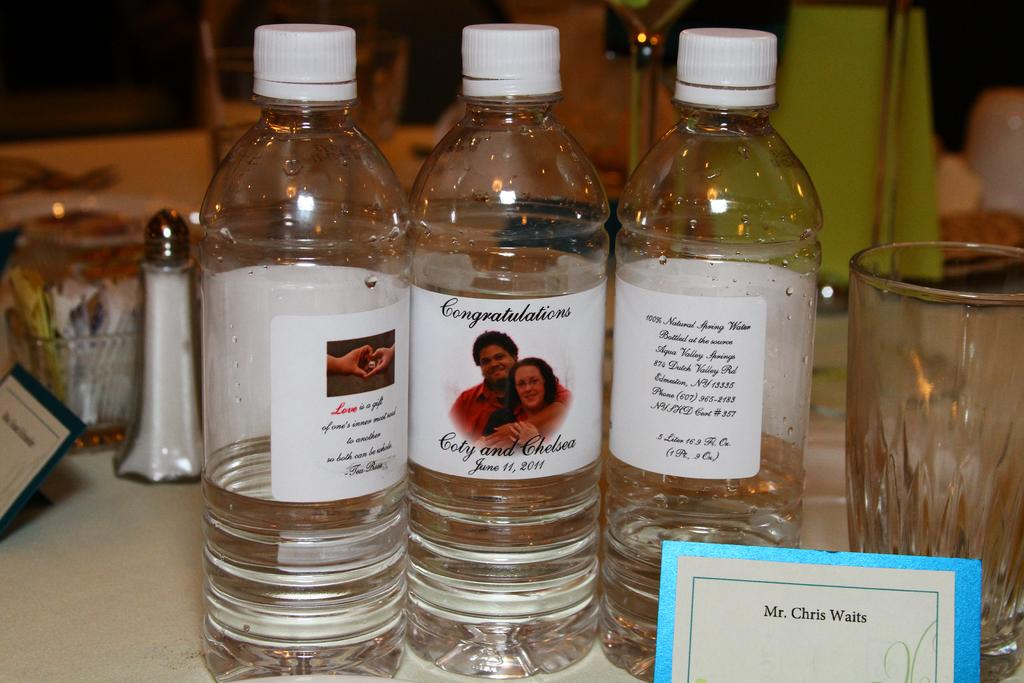<image>
Share a concise interpretation of the image provided. Three bottles of showing the front and back of the bottles that are congratulating Cody and Chelsea June 11, 2011. 